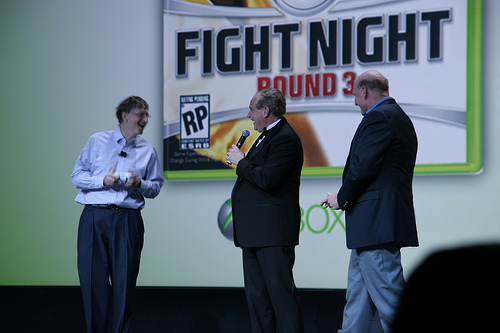<image>
Can you confirm if the jacket is on the man? No. The jacket is not positioned on the man. They may be near each other, but the jacket is not supported by or resting on top of the man. Where is the person in relation to the screen? Is it next to the screen? Yes. The person is positioned adjacent to the screen, located nearby in the same general area. 